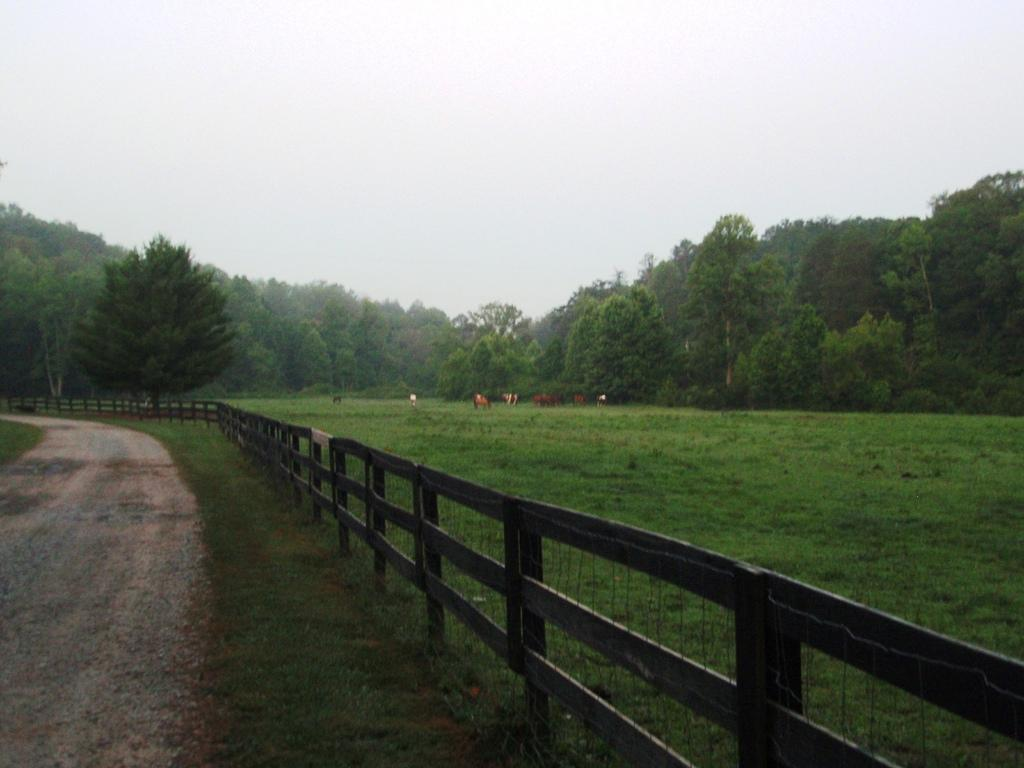What is located in the foreground of the image? In the foreground of the image, there is a railing, grass, a path, trees, and animals. Can you describe the ground surface in the foreground of the image? The ground surface in the foreground of the image consists of grass and a path. What type of vegetation is present in the foreground of the image? Trees are present in the foreground of the image. What is visible in the background of the image? The sky is visible in the image. How many fingers can be seen holding the animals in the image? There are no fingers visible holding the animals in the image. What type of trick is being performed with the animals in the image? There is no trick being performed with the animals in the image. What type of club is present in the image? There is no club present in the image. 